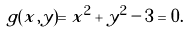Convert formula to latex. <formula><loc_0><loc_0><loc_500><loc_500>g ( x , y ) = x ^ { 2 } + y ^ { 2 } - 3 = 0 .</formula> 